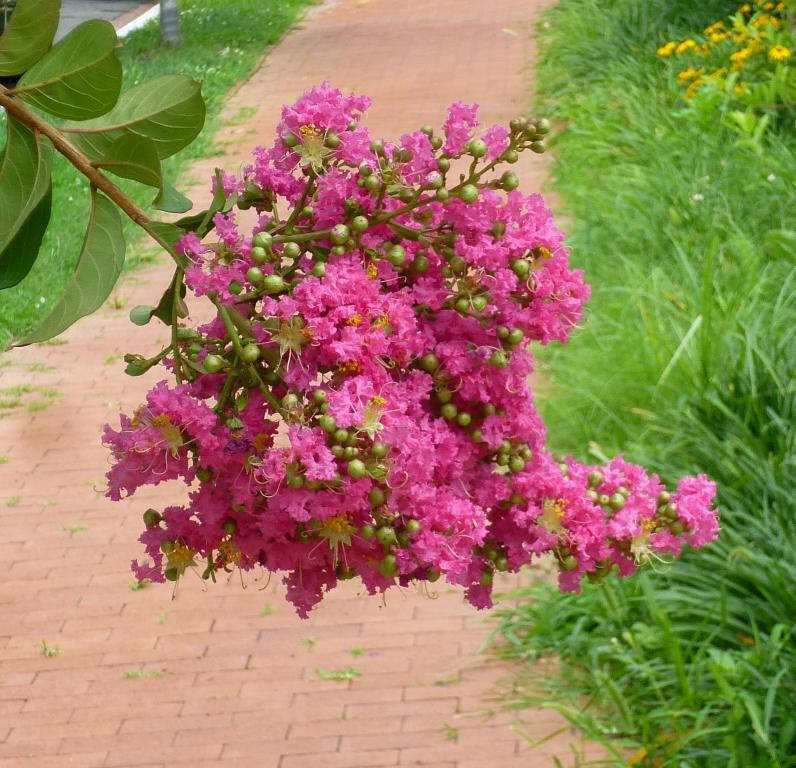What type of flowers are in the middle of the image? There are pink flowers in the middle of the image. What surrounds the flowers in the image? There is grass on either side of the flowers. What material is used to create the path at the bottom of the image? The path at the bottom of the image is made of bricks. What color paint is used to cover the net in the image? There is no net or paint present in the image. 